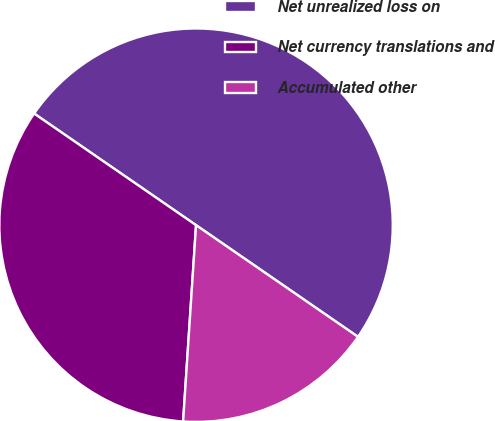Convert chart. <chart><loc_0><loc_0><loc_500><loc_500><pie_chart><fcel>Net unrealized loss on<fcel>Net currency translations and<fcel>Accumulated other<nl><fcel>50.0%<fcel>33.56%<fcel>16.44%<nl></chart> 